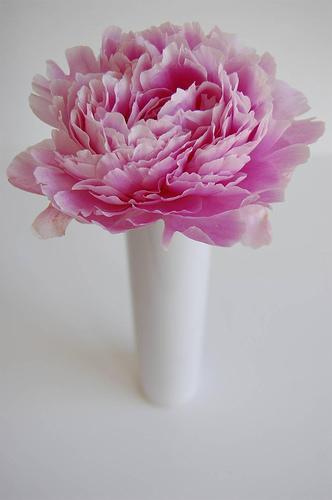How many different types of flowers are in the vase?
Give a very brief answer. 1. How many flowers are in the vase?
Give a very brief answer. 1. How many different objects are in this image?
Give a very brief answer. 2. How many people in the boat?
Give a very brief answer. 0. 